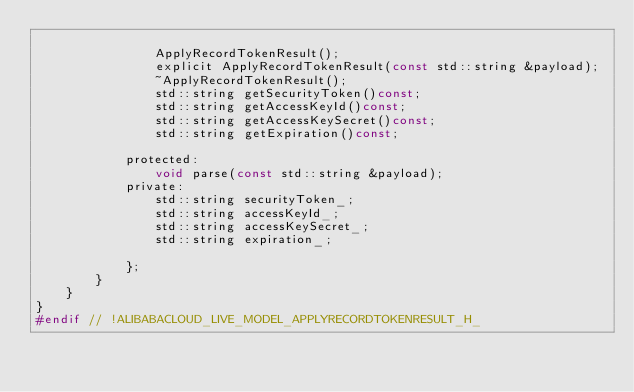Convert code to text. <code><loc_0><loc_0><loc_500><loc_500><_C_>
				ApplyRecordTokenResult();
				explicit ApplyRecordTokenResult(const std::string &payload);
				~ApplyRecordTokenResult();
				std::string getSecurityToken()const;
				std::string getAccessKeyId()const;
				std::string getAccessKeySecret()const;
				std::string getExpiration()const;

			protected:
				void parse(const std::string &payload);
			private:
				std::string securityToken_;
				std::string accessKeyId_;
				std::string accessKeySecret_;
				std::string expiration_;

			};
		}
	}
}
#endif // !ALIBABACLOUD_LIVE_MODEL_APPLYRECORDTOKENRESULT_H_</code> 